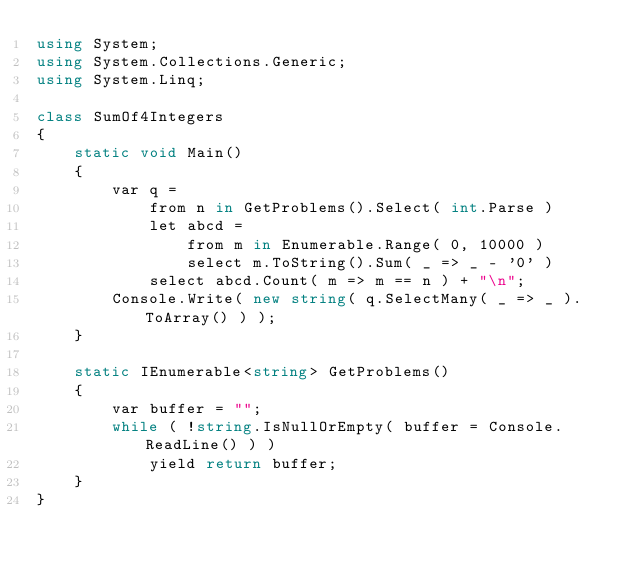Convert code to text. <code><loc_0><loc_0><loc_500><loc_500><_C#_>using System;
using System.Collections.Generic;
using System.Linq;

class SumOf4Integers 
{
    static void Main()
    {
        var q =
            from n in GetProblems().Select( int.Parse )
            let abcd =
                from m in Enumerable.Range( 0, 10000 )
                select m.ToString().Sum( _ => _ - '0' )
            select abcd.Count( m => m == n ) + "\n";
        Console.Write( new string( q.SelectMany( _ => _ ).ToArray() ) );
    }

    static IEnumerable<string> GetProblems()
    {
        var buffer = "";
        while ( !string.IsNullOrEmpty( buffer = Console.ReadLine() ) )
            yield return buffer;
    }
}</code> 